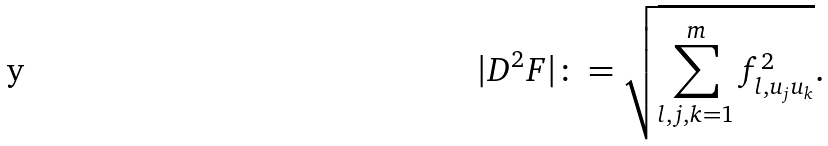Convert formula to latex. <formula><loc_0><loc_0><loc_500><loc_500>| D ^ { 2 } F | \colon = \sqrt { \sum _ { l , j , k = 1 } ^ { m } f ^ { 2 } _ { l , u _ { j } u _ { k } } } .</formula> 